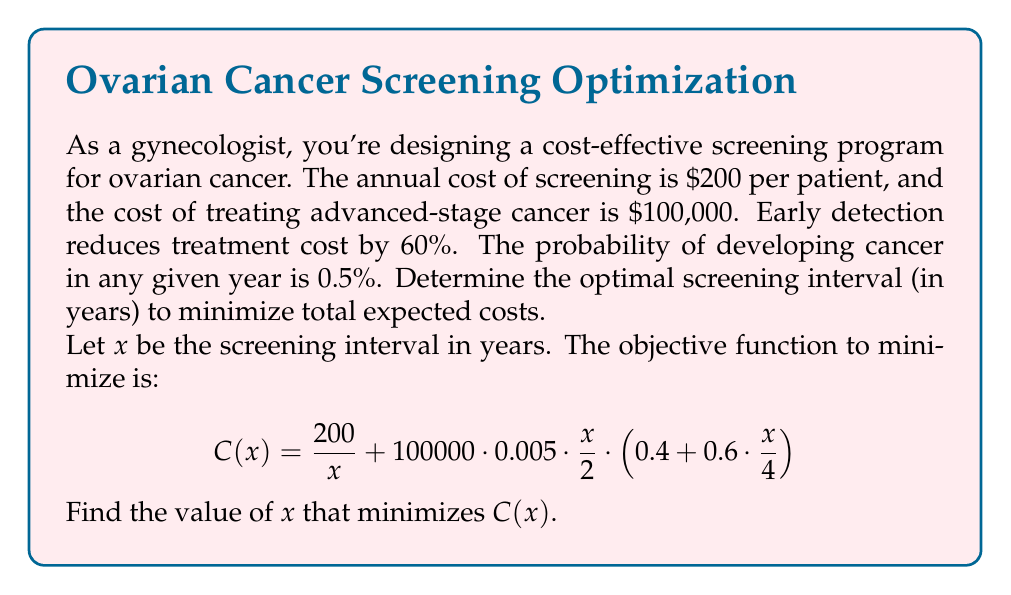What is the answer to this math problem? To solve this optimization problem, we'll follow these steps:

1) First, let's understand the components of the cost function $C(x)$:
   - $\frac{200}{x}$ is the annual screening cost
   - $100000 \cdot 0.005 \cdot \frac{x}{2}$ is the expected cost of cancer occurring
   - $(0.4 + 0.6 \cdot \frac{x}{4})$ accounts for the reduced cost due to early detection

2) To find the minimum, we differentiate $C(x)$ with respect to $x$ and set it to zero:

   $$C'(x) = -\frac{200}{x^2} + 250 \cdot (0.4 + 0.6 \cdot \frac{x}{4}) + 250 \cdot \frac{x}{2} \cdot 0.6 \cdot \frac{1}{4} = 0$$

3) Simplify:
   
   $$-\frac{200}{x^2} + 100 + 37.5x + 37.5 = 0$$

4) Multiply all terms by $x^2$:

   $$-200 + 100x^2 + 37.5x^3 + 37.5x^2 = 0$$

5) Rearrange:

   $$37.5x^3 + 137.5x^2 - 200 = 0$$

6) This cubic equation doesn't have a nice analytical solution. We can solve it numerically or graphically.

7) Using a numerical method (e.g., Newton-Raphson), we find that $x \approx 1.48$ years.

8) To verify, we can check the second derivative $C''(x)$ at this point to confirm it's positive, ensuring we've found a minimum.
Answer: The optimal screening interval is approximately 1.48 years. 